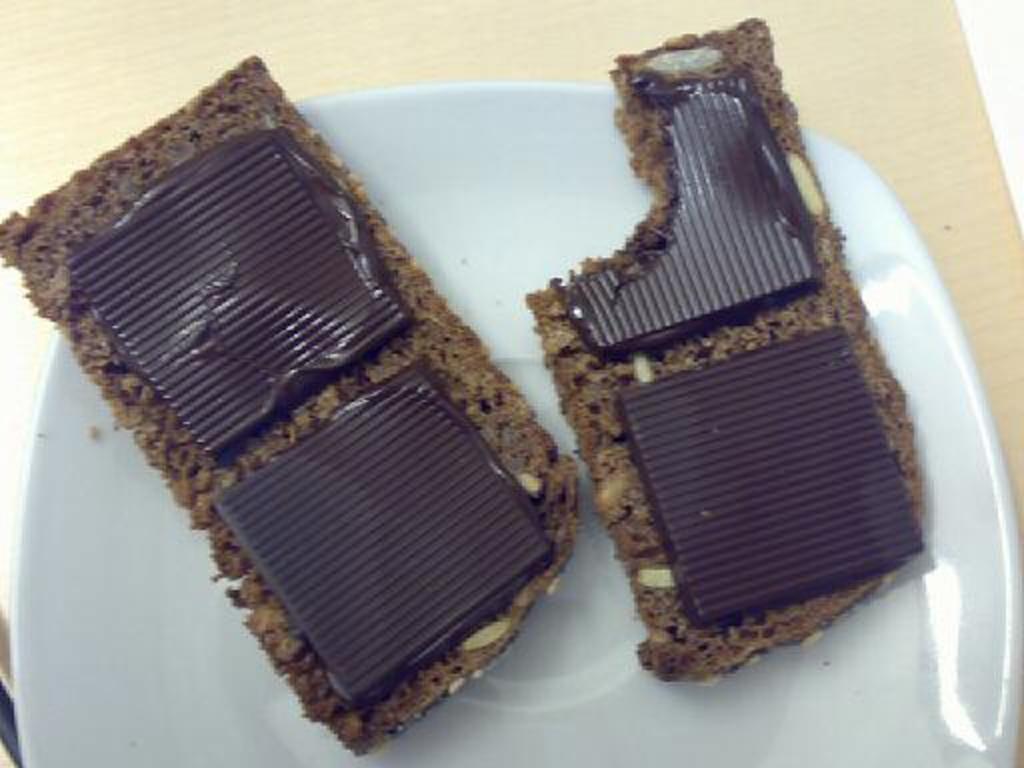Please provide a concise description of this image. In this image I can see a plate in which chocolate bars are there which are kept on the table. This image is taken in a room. 